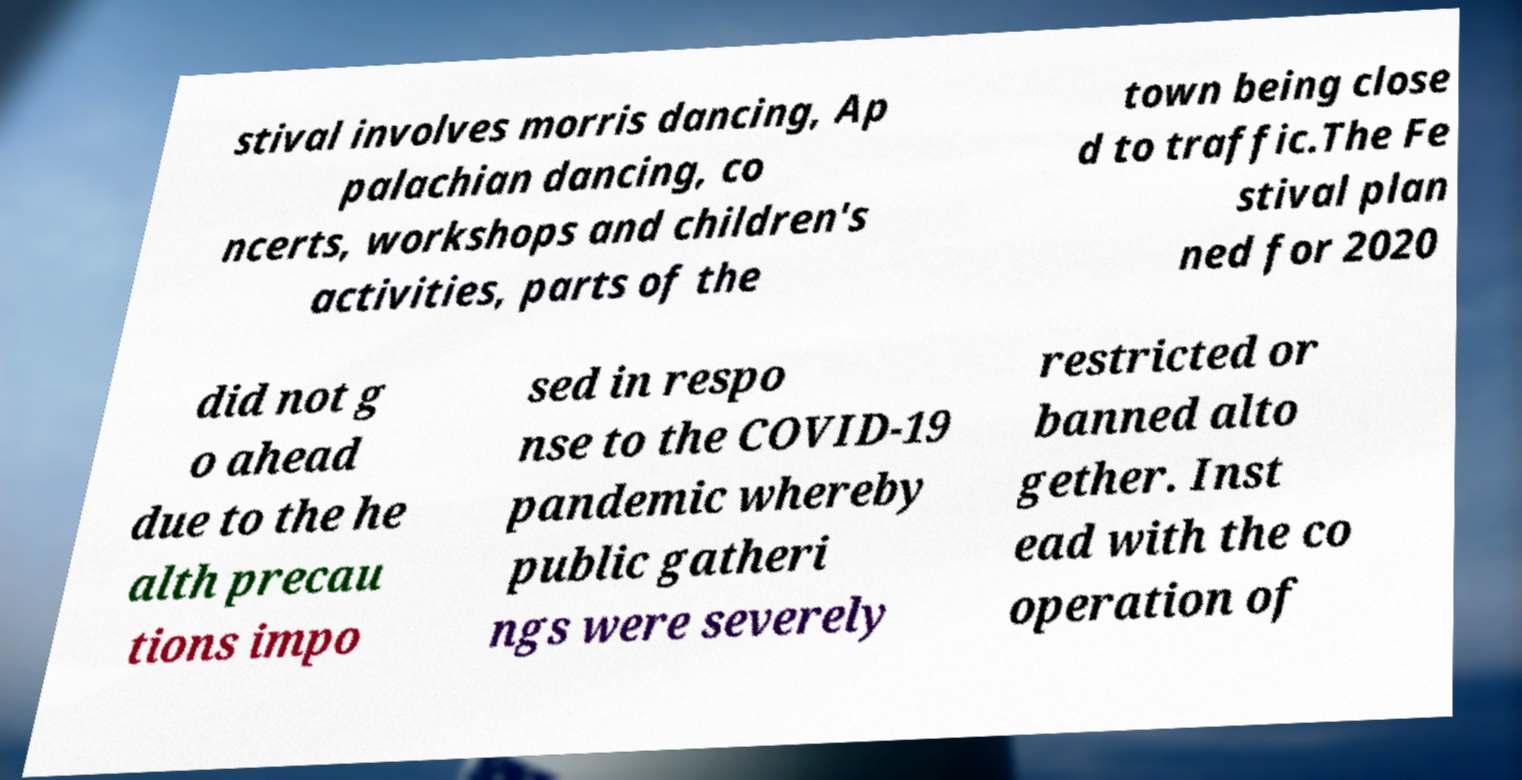There's text embedded in this image that I need extracted. Can you transcribe it verbatim? stival involves morris dancing, Ap palachian dancing, co ncerts, workshops and children's activities, parts of the town being close d to traffic.The Fe stival plan ned for 2020 did not g o ahead due to the he alth precau tions impo sed in respo nse to the COVID-19 pandemic whereby public gatheri ngs were severely restricted or banned alto gether. Inst ead with the co operation of 